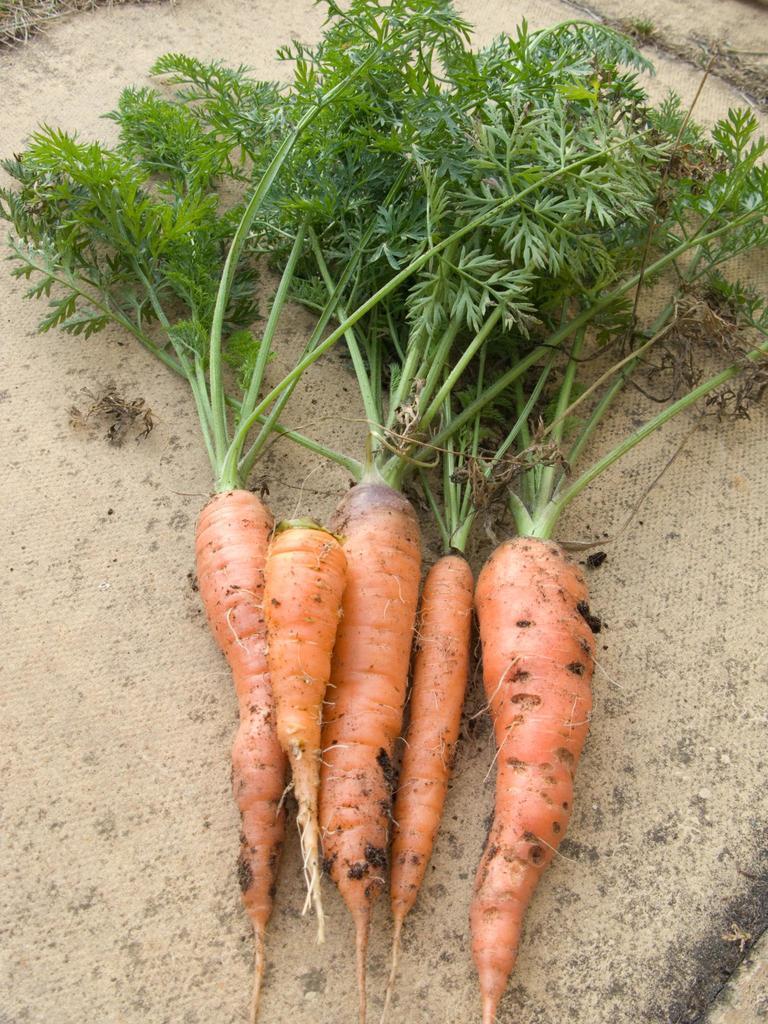In one or two sentences, can you explain what this image depicts? In this image, we can see carrots with leaves and at the bottom, there is ground. 